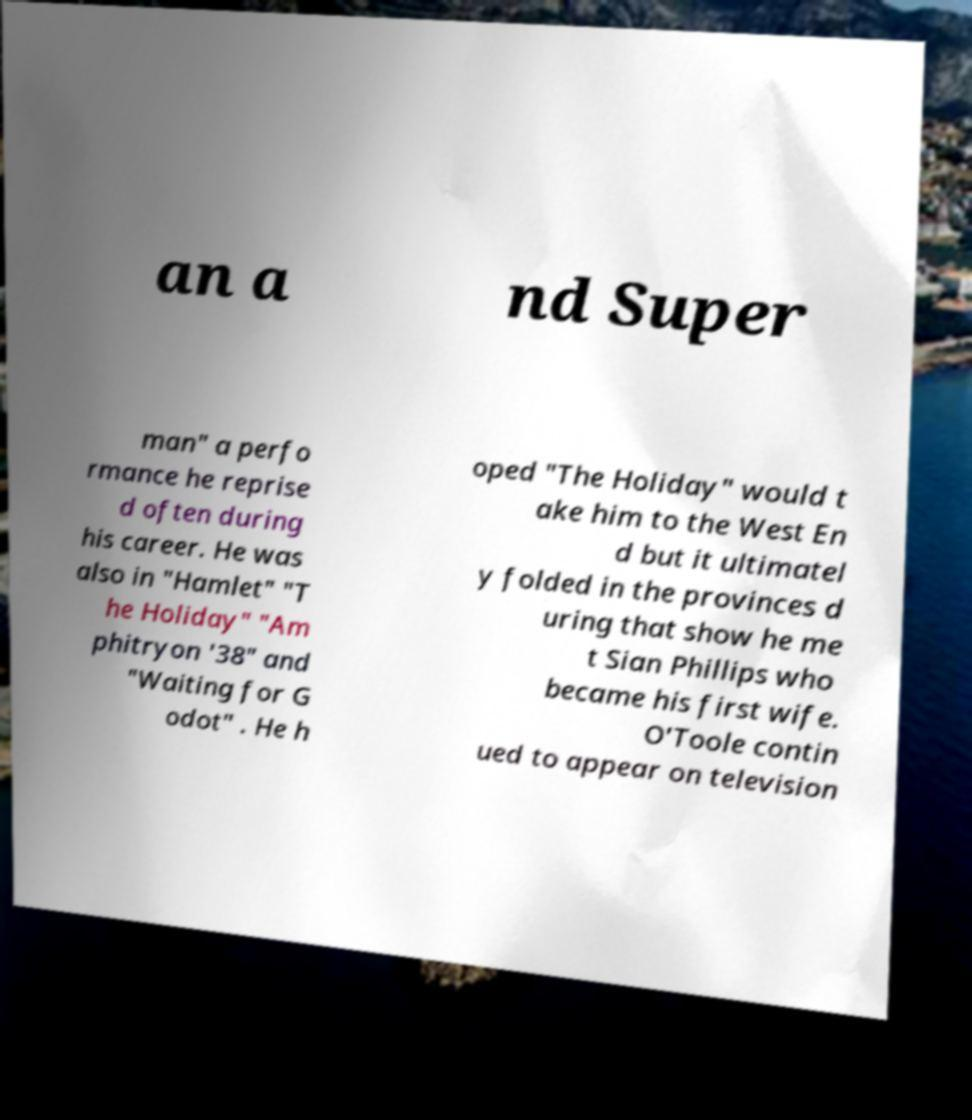There's text embedded in this image that I need extracted. Can you transcribe it verbatim? an a nd Super man" a perfo rmance he reprise d often during his career. He was also in "Hamlet" "T he Holiday" "Am phitryon '38" and "Waiting for G odot" . He h oped "The Holiday" would t ake him to the West En d but it ultimatel y folded in the provinces d uring that show he me t Sian Phillips who became his first wife. O'Toole contin ued to appear on television 